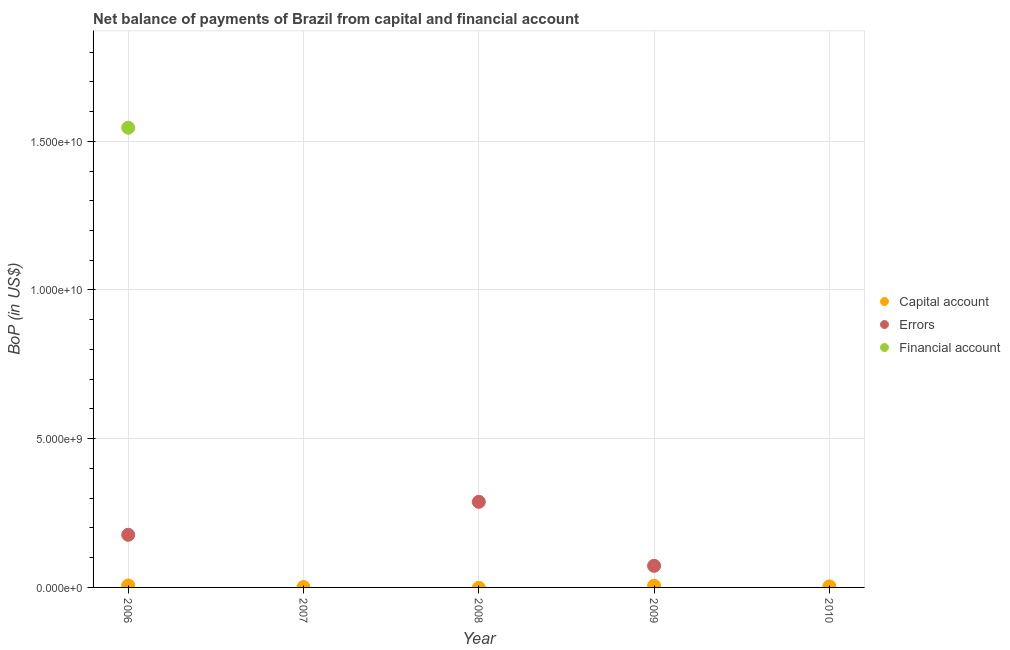How many different coloured dotlines are there?
Your response must be concise. 3. What is the amount of net capital account in 2007?
Provide a short and direct response. 1.22e+07. Across all years, what is the maximum amount of financial account?
Provide a short and direct response. 1.55e+1. In which year was the amount of net capital account maximum?
Provide a short and direct response. 2006. What is the total amount of net capital account in the graph?
Provide a succinct answer. 1.68e+08. What is the difference between the amount of errors in 2008 and that in 2009?
Your answer should be very brief. 2.15e+09. What is the difference between the amount of net capital account in 2010 and the amount of financial account in 2006?
Your answer should be very brief. -1.54e+1. What is the average amount of errors per year?
Offer a terse response. 1.07e+09. In the year 2009, what is the difference between the amount of errors and amount of net capital account?
Ensure brevity in your answer.  6.71e+08. In how many years, is the amount of net capital account greater than 6000000000 US$?
Make the answer very short. 0. What is the difference between the highest and the second highest amount of errors?
Keep it short and to the point. 1.11e+09. What is the difference between the highest and the lowest amount of net capital account?
Provide a short and direct response. 6.50e+07. In how many years, is the amount of net capital account greater than the average amount of net capital account taken over all years?
Your answer should be compact. 3. Is the sum of the amount of errors in 2006 and 2009 greater than the maximum amount of net capital account across all years?
Give a very brief answer. Yes. Is it the case that in every year, the sum of the amount of net capital account and amount of errors is greater than the amount of financial account?
Your answer should be compact. No. Is the amount of errors strictly greater than the amount of financial account over the years?
Keep it short and to the point. No. How many dotlines are there?
Your answer should be compact. 3. How many years are there in the graph?
Give a very brief answer. 5. Are the values on the major ticks of Y-axis written in scientific E-notation?
Your answer should be very brief. Yes. Where does the legend appear in the graph?
Offer a very short reply. Center right. How many legend labels are there?
Your answer should be compact. 3. What is the title of the graph?
Your answer should be compact. Net balance of payments of Brazil from capital and financial account. What is the label or title of the Y-axis?
Keep it short and to the point. BoP (in US$). What is the BoP (in US$) in Capital account in 2006?
Your answer should be very brief. 6.50e+07. What is the BoP (in US$) in Errors in 2006?
Provide a succinct answer. 1.77e+09. What is the BoP (in US$) of Financial account in 2006?
Provide a succinct answer. 1.55e+1. What is the BoP (in US$) in Capital account in 2007?
Keep it short and to the point. 1.22e+07. What is the BoP (in US$) in Capital account in 2008?
Offer a very short reply. 0. What is the BoP (in US$) of Errors in 2008?
Provide a short and direct response. 2.88e+09. What is the BoP (in US$) in Financial account in 2008?
Keep it short and to the point. 0. What is the BoP (in US$) of Capital account in 2009?
Ensure brevity in your answer.  5.56e+07. What is the BoP (in US$) of Errors in 2009?
Your answer should be very brief. 7.26e+08. What is the BoP (in US$) in Financial account in 2009?
Provide a succinct answer. 0. What is the BoP (in US$) of Capital account in 2010?
Offer a very short reply. 3.52e+07. What is the BoP (in US$) of Errors in 2010?
Offer a terse response. 0. What is the BoP (in US$) of Financial account in 2010?
Your answer should be very brief. 0. Across all years, what is the maximum BoP (in US$) in Capital account?
Your answer should be compact. 6.50e+07. Across all years, what is the maximum BoP (in US$) in Errors?
Make the answer very short. 2.88e+09. Across all years, what is the maximum BoP (in US$) of Financial account?
Provide a short and direct response. 1.55e+1. Across all years, what is the minimum BoP (in US$) in Capital account?
Keep it short and to the point. 0. What is the total BoP (in US$) of Capital account in the graph?
Ensure brevity in your answer.  1.68e+08. What is the total BoP (in US$) in Errors in the graph?
Keep it short and to the point. 5.37e+09. What is the total BoP (in US$) of Financial account in the graph?
Offer a terse response. 1.55e+1. What is the difference between the BoP (in US$) of Capital account in 2006 and that in 2007?
Keep it short and to the point. 5.27e+07. What is the difference between the BoP (in US$) of Errors in 2006 and that in 2008?
Provide a succinct answer. -1.11e+09. What is the difference between the BoP (in US$) of Capital account in 2006 and that in 2009?
Provide a succinct answer. 9.41e+06. What is the difference between the BoP (in US$) in Errors in 2006 and that in 2009?
Offer a very short reply. 1.04e+09. What is the difference between the BoP (in US$) in Capital account in 2006 and that in 2010?
Your answer should be very brief. 2.98e+07. What is the difference between the BoP (in US$) of Capital account in 2007 and that in 2009?
Offer a very short reply. -4.33e+07. What is the difference between the BoP (in US$) in Capital account in 2007 and that in 2010?
Offer a very short reply. -2.30e+07. What is the difference between the BoP (in US$) in Errors in 2008 and that in 2009?
Offer a terse response. 2.15e+09. What is the difference between the BoP (in US$) in Capital account in 2009 and that in 2010?
Give a very brief answer. 2.03e+07. What is the difference between the BoP (in US$) in Capital account in 2006 and the BoP (in US$) in Errors in 2008?
Your response must be concise. -2.81e+09. What is the difference between the BoP (in US$) of Capital account in 2006 and the BoP (in US$) of Errors in 2009?
Your answer should be very brief. -6.61e+08. What is the difference between the BoP (in US$) in Capital account in 2007 and the BoP (in US$) in Errors in 2008?
Offer a terse response. -2.87e+09. What is the difference between the BoP (in US$) in Capital account in 2007 and the BoP (in US$) in Errors in 2009?
Make the answer very short. -7.14e+08. What is the average BoP (in US$) in Capital account per year?
Give a very brief answer. 3.36e+07. What is the average BoP (in US$) in Errors per year?
Ensure brevity in your answer.  1.07e+09. What is the average BoP (in US$) of Financial account per year?
Make the answer very short. 3.09e+09. In the year 2006, what is the difference between the BoP (in US$) of Capital account and BoP (in US$) of Errors?
Provide a short and direct response. -1.70e+09. In the year 2006, what is the difference between the BoP (in US$) of Capital account and BoP (in US$) of Financial account?
Your response must be concise. -1.54e+1. In the year 2006, what is the difference between the BoP (in US$) in Errors and BoP (in US$) in Financial account?
Provide a succinct answer. -1.37e+1. In the year 2009, what is the difference between the BoP (in US$) in Capital account and BoP (in US$) in Errors?
Your answer should be compact. -6.71e+08. What is the ratio of the BoP (in US$) of Capital account in 2006 to that in 2007?
Make the answer very short. 5.31. What is the ratio of the BoP (in US$) in Errors in 2006 to that in 2008?
Your answer should be compact. 0.61. What is the ratio of the BoP (in US$) in Capital account in 2006 to that in 2009?
Provide a succinct answer. 1.17. What is the ratio of the BoP (in US$) of Errors in 2006 to that in 2009?
Give a very brief answer. 2.44. What is the ratio of the BoP (in US$) in Capital account in 2006 to that in 2010?
Ensure brevity in your answer.  1.84. What is the ratio of the BoP (in US$) in Capital account in 2007 to that in 2009?
Provide a short and direct response. 0.22. What is the ratio of the BoP (in US$) of Capital account in 2007 to that in 2010?
Provide a succinct answer. 0.35. What is the ratio of the BoP (in US$) of Errors in 2008 to that in 2009?
Keep it short and to the point. 3.96. What is the ratio of the BoP (in US$) of Capital account in 2009 to that in 2010?
Make the answer very short. 1.58. What is the difference between the highest and the second highest BoP (in US$) of Capital account?
Ensure brevity in your answer.  9.41e+06. What is the difference between the highest and the second highest BoP (in US$) in Errors?
Provide a succinct answer. 1.11e+09. What is the difference between the highest and the lowest BoP (in US$) in Capital account?
Keep it short and to the point. 6.50e+07. What is the difference between the highest and the lowest BoP (in US$) of Errors?
Offer a very short reply. 2.88e+09. What is the difference between the highest and the lowest BoP (in US$) of Financial account?
Your response must be concise. 1.55e+1. 